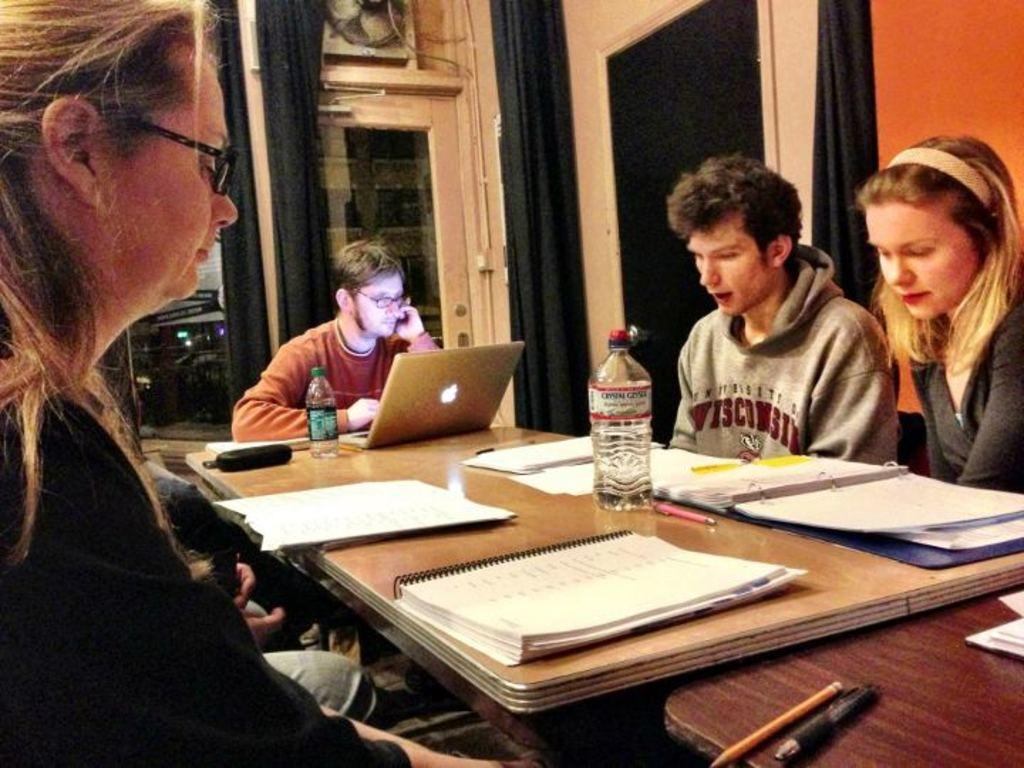What are the persons in the image doing? The persons in the image are sitting. What is on the table in the image? There are books, a pen, a bottle, and a laptop on the table. What can be seen in the background of the image? There is a curtain and a wall in the background of the image. How many beds are visible in the image? There are no beds visible in the image. What type of wound can be seen on the person's arm in the image? There is no wound visible on any person's arm in the image. 